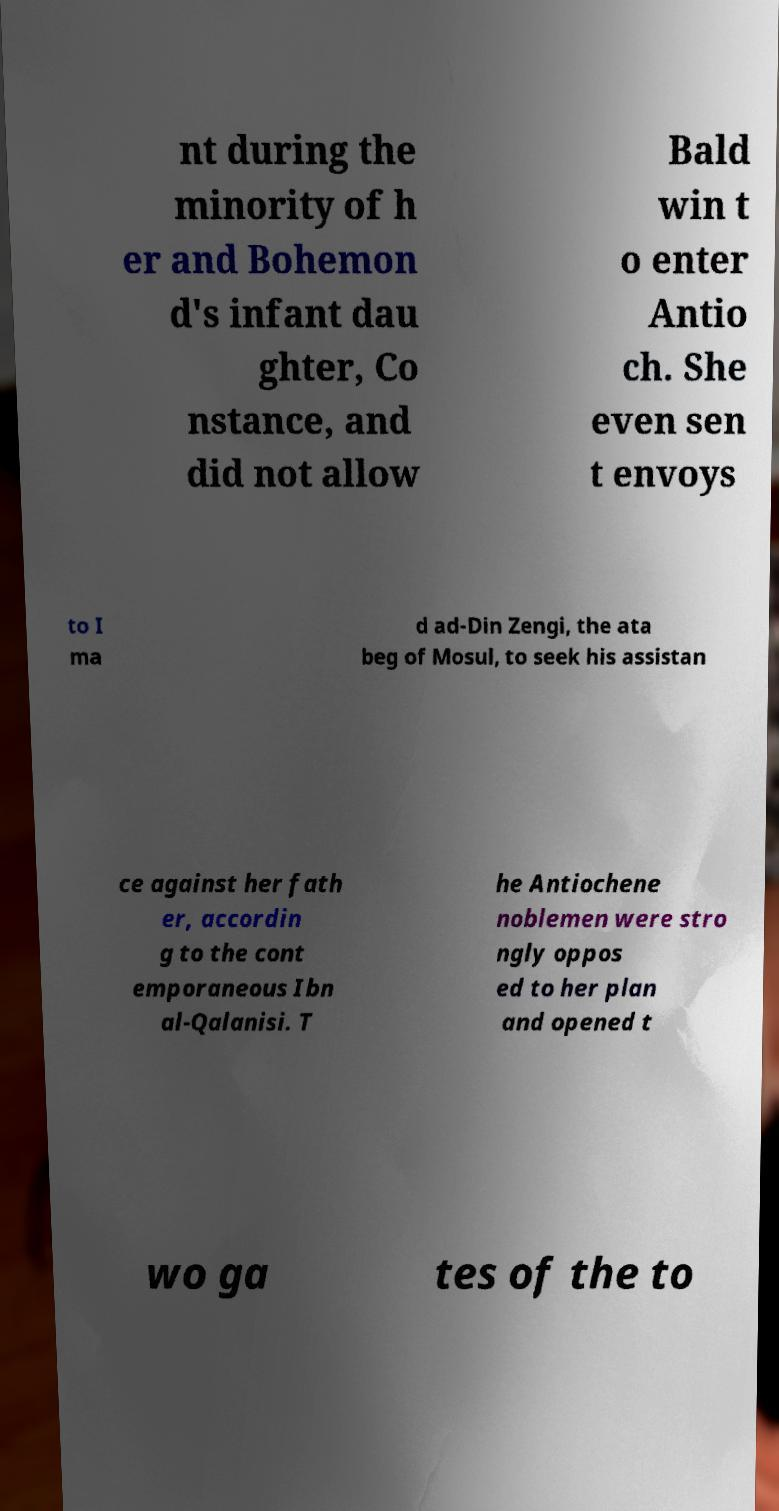Can you read and provide the text displayed in the image?This photo seems to have some interesting text. Can you extract and type it out for me? nt during the minority of h er and Bohemon d's infant dau ghter, Co nstance, and did not allow Bald win t o enter Antio ch. She even sen t envoys to I ma d ad-Din Zengi, the ata beg of Mosul, to seek his assistan ce against her fath er, accordin g to the cont emporaneous Ibn al-Qalanisi. T he Antiochene noblemen were stro ngly oppos ed to her plan and opened t wo ga tes of the to 